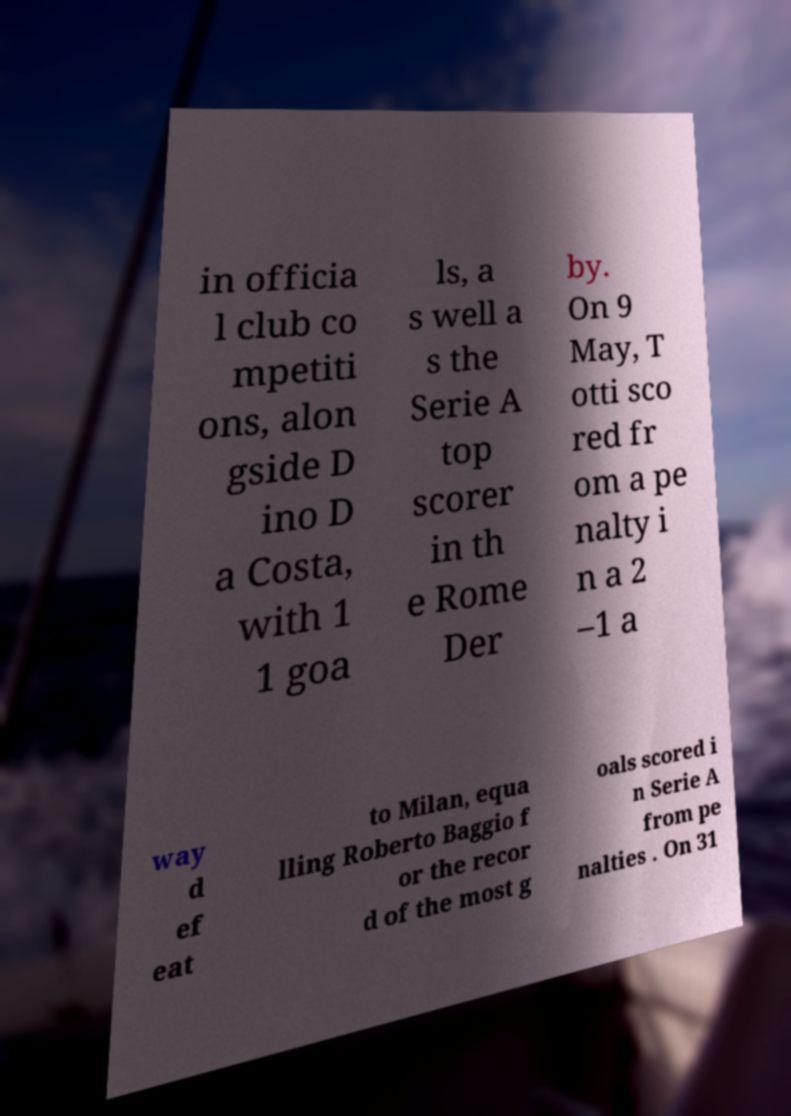Can you accurately transcribe the text from the provided image for me? in officia l club co mpetiti ons, alon gside D ino D a Costa, with 1 1 goa ls, a s well a s the Serie A top scorer in th e Rome Der by. On 9 May, T otti sco red fr om a pe nalty i n a 2 –1 a way d ef eat to Milan, equa lling Roberto Baggio f or the recor d of the most g oals scored i n Serie A from pe nalties . On 31 